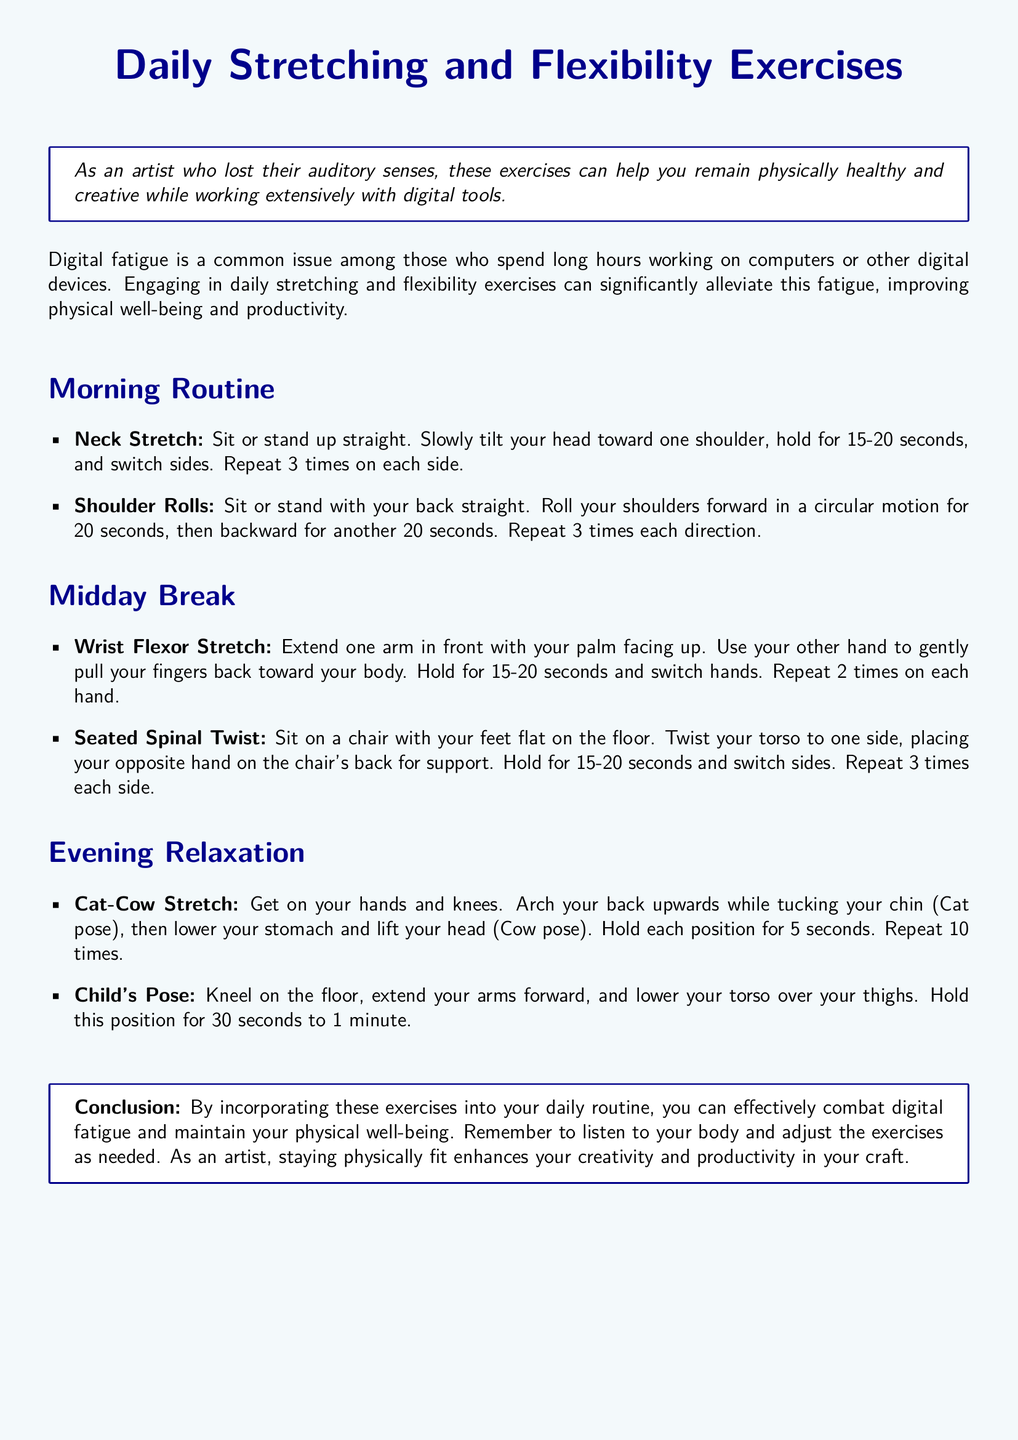what are the benefits of stretching exercises? The document mentions that engaging in daily stretching and flexibility exercises can alleviate digital fatigue, improving physical well-being and productivity.
Answer: alleviate digital fatigue how long should you hold a Neck Stretch? The Neck Stretch should be held for 15-20 seconds on each side.
Answer: 15-20 seconds what is the first exercise listed in the Morning Routine? The first exercise listed is the Neck Stretch.
Answer: Neck Stretch how many times should you repeat the Shoulder Rolls? You should repeat the Shoulder Rolls 3 times each direction.
Answer: 3 times what is the concluding advice in the document? The conclusion emphasizes listening to your body and adjusting the exercises as needed to maintain physical well-being.
Answer: listen to your body how should you perform the Child's Pose? The Child's Pose is performed by kneeling, extending arms forward, and lowering the torso over the thighs.
Answer: kneel, extend arms forward, lower torso what is the purpose of the Midday Break exercises? The Midday Break exercises aim to alleviate fatigue from long hours of digital work.
Answer: alleviate fatigue how many times should you repeat the Cat-Cow Stretch? The Cat-Cow Stretch should be repeated 10 times.
Answer: 10 times 